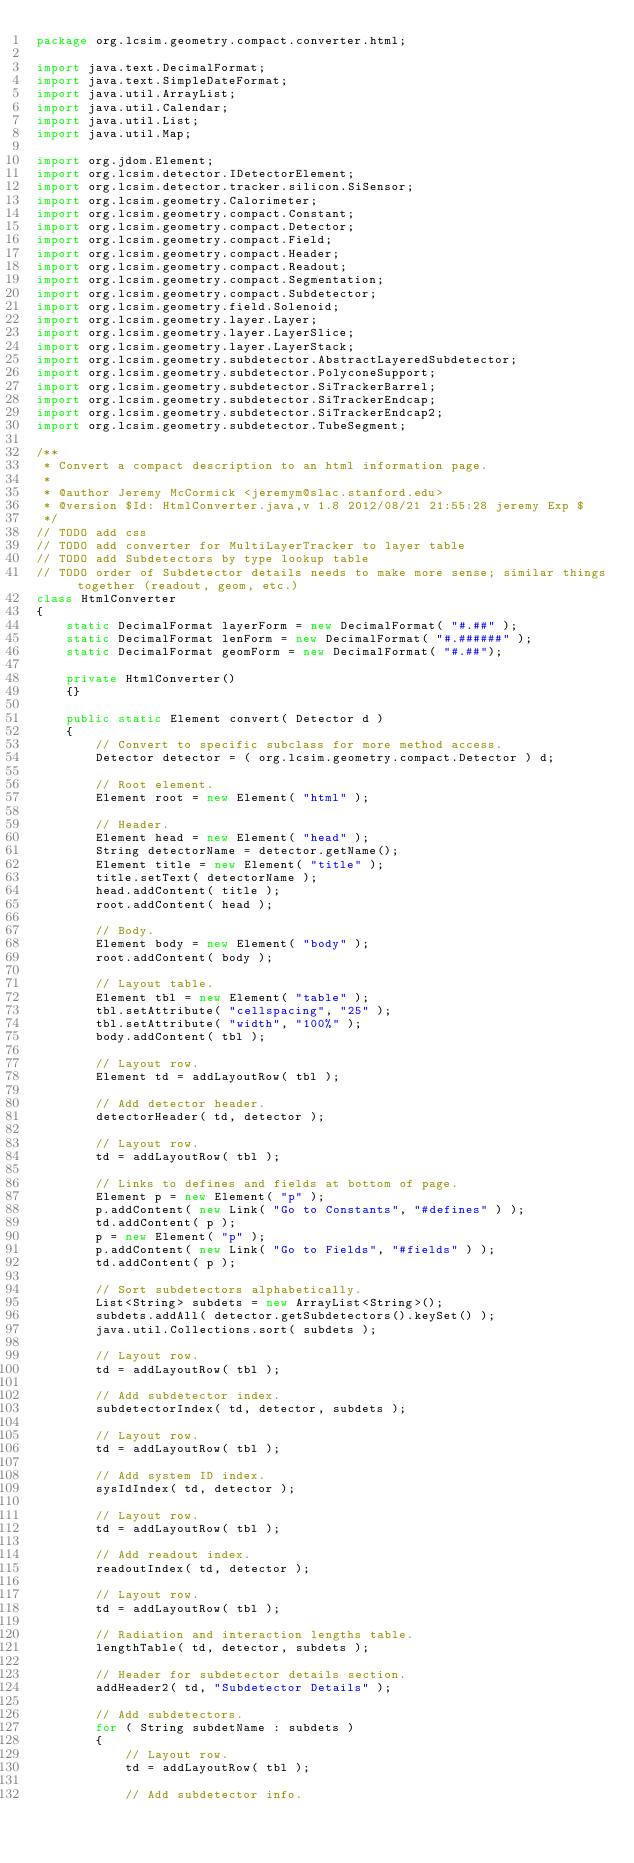<code> <loc_0><loc_0><loc_500><loc_500><_Java_>package org.lcsim.geometry.compact.converter.html;

import java.text.DecimalFormat;
import java.text.SimpleDateFormat;
import java.util.ArrayList;
import java.util.Calendar;
import java.util.List;
import java.util.Map;

import org.jdom.Element;
import org.lcsim.detector.IDetectorElement;
import org.lcsim.detector.tracker.silicon.SiSensor;
import org.lcsim.geometry.Calorimeter;
import org.lcsim.geometry.compact.Constant;
import org.lcsim.geometry.compact.Detector;
import org.lcsim.geometry.compact.Field;
import org.lcsim.geometry.compact.Header;
import org.lcsim.geometry.compact.Readout;
import org.lcsim.geometry.compact.Segmentation;
import org.lcsim.geometry.compact.Subdetector;
import org.lcsim.geometry.field.Solenoid;
import org.lcsim.geometry.layer.Layer;
import org.lcsim.geometry.layer.LayerSlice;
import org.lcsim.geometry.layer.LayerStack;
import org.lcsim.geometry.subdetector.AbstractLayeredSubdetector;
import org.lcsim.geometry.subdetector.PolyconeSupport;
import org.lcsim.geometry.subdetector.SiTrackerBarrel;
import org.lcsim.geometry.subdetector.SiTrackerEndcap;
import org.lcsim.geometry.subdetector.SiTrackerEndcap2;
import org.lcsim.geometry.subdetector.TubeSegment;

/**
 * Convert a compact description to an html information page.
 * 
 * @author Jeremy McCormick <jeremym@slac.stanford.edu>
 * @version $Id: HtmlConverter.java,v 1.8 2012/08/21 21:55:28 jeremy Exp $
 */
// TODO add css
// TODO add converter for MultiLayerTracker to layer table
// TODO add Subdetectors by type lookup table
// TODO order of Subdetector details needs to make more sense; similar things together (readout, geom, etc.)
class HtmlConverter
{
    static DecimalFormat layerForm = new DecimalFormat( "#.##" );
    static DecimalFormat lenForm = new DecimalFormat( "#.######" );
    static DecimalFormat geomForm = new DecimalFormat( "#.##");

    private HtmlConverter()
    {}

    public static Element convert( Detector d )
    {
        // Convert to specific subclass for more method access.
        Detector detector = ( org.lcsim.geometry.compact.Detector ) d;

        // Root element.
        Element root = new Element( "html" );

        // Header.
        Element head = new Element( "head" );
        String detectorName = detector.getName();
        Element title = new Element( "title" );
        title.setText( detectorName );
        head.addContent( title );
        root.addContent( head );

        // Body.
        Element body = new Element( "body" );
        root.addContent( body );

        // Layout table.
        Element tbl = new Element( "table" );
        tbl.setAttribute( "cellspacing", "25" );
        tbl.setAttribute( "width", "100%" );
        body.addContent( tbl );

        // Layout row.
        Element td = addLayoutRow( tbl );

        // Add detector header.
        detectorHeader( td, detector );

        // Layout row.
        td = addLayoutRow( tbl );

        // Links to defines and fields at bottom of page.
        Element p = new Element( "p" );
        p.addContent( new Link( "Go to Constants", "#defines" ) );
        td.addContent( p );
        p = new Element( "p" );
        p.addContent( new Link( "Go to Fields", "#fields" ) );
        td.addContent( p );

        // Sort subdetectors alphabetically.
        List<String> subdets = new ArrayList<String>();
        subdets.addAll( detector.getSubdetectors().keySet() );
        java.util.Collections.sort( subdets );

        // Layout row.
        td = addLayoutRow( tbl );

        // Add subdetector index.
        subdetectorIndex( td, detector, subdets );

        // Layout row.
        td = addLayoutRow( tbl );

        // Add system ID index.
        sysIdIndex( td, detector );

        // Layout row.
        td = addLayoutRow( tbl );

        // Add readout index.
        readoutIndex( td, detector );

        // Layout row.
        td = addLayoutRow( tbl );

        // Radiation and interaction lengths table.
        lengthTable( td, detector, subdets );

        // Header for subdetector details section.
        addHeader2( td, "Subdetector Details" );

        // Add subdetectors.
        for ( String subdetName : subdets )
        {
            // Layout row.
            td = addLayoutRow( tbl );

            // Add subdetector info.</code> 